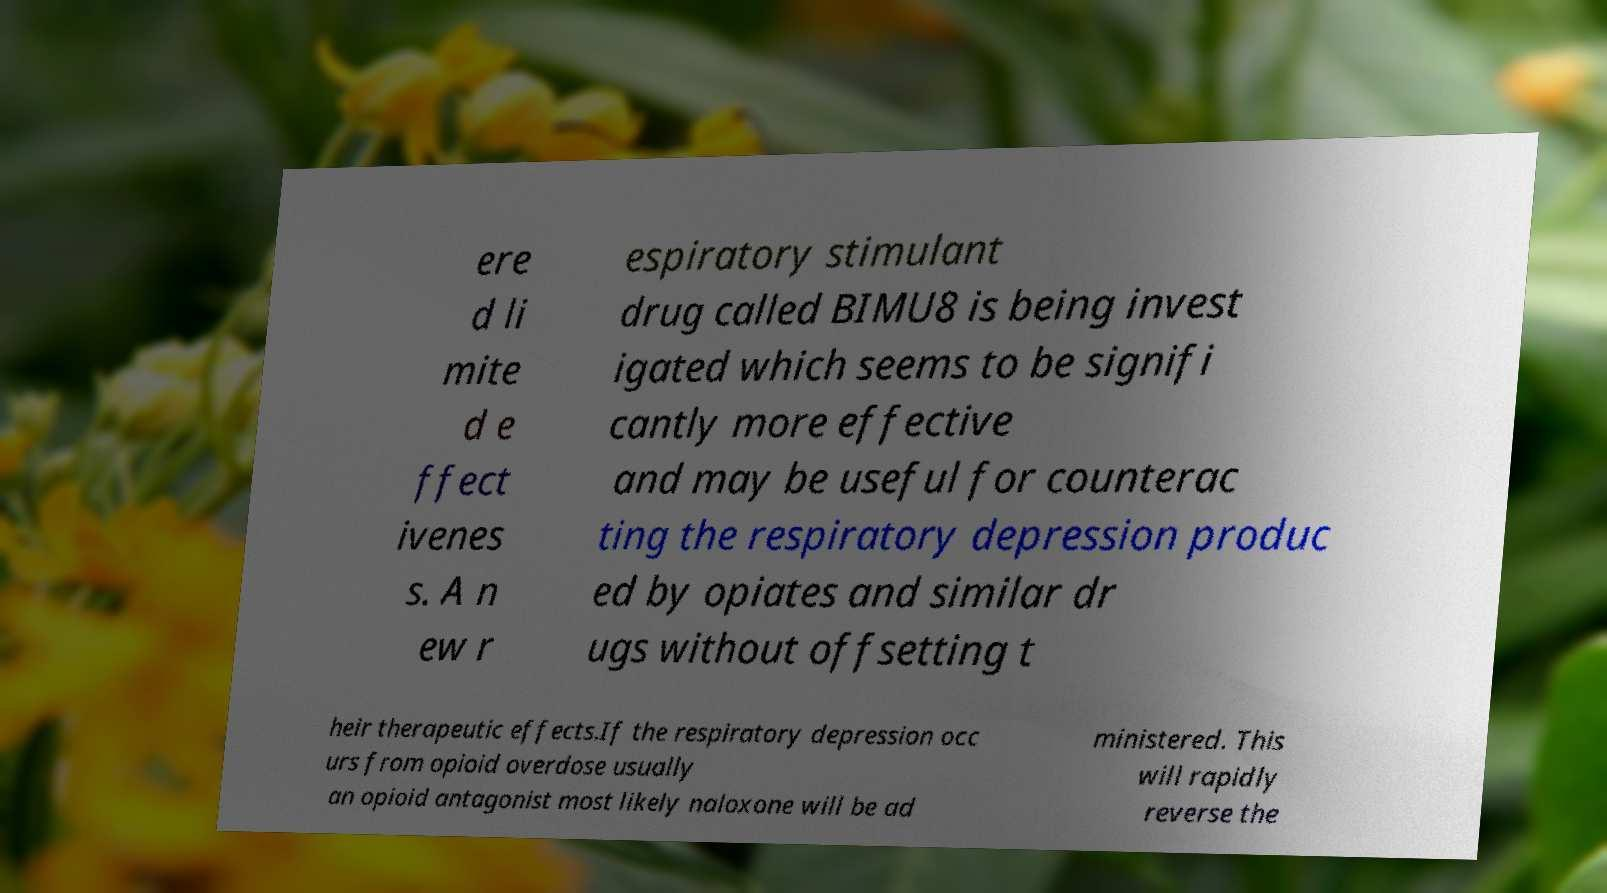Please identify and transcribe the text found in this image. ere d li mite d e ffect ivenes s. A n ew r espiratory stimulant drug called BIMU8 is being invest igated which seems to be signifi cantly more effective and may be useful for counterac ting the respiratory depression produc ed by opiates and similar dr ugs without offsetting t heir therapeutic effects.If the respiratory depression occ urs from opioid overdose usually an opioid antagonist most likely naloxone will be ad ministered. This will rapidly reverse the 